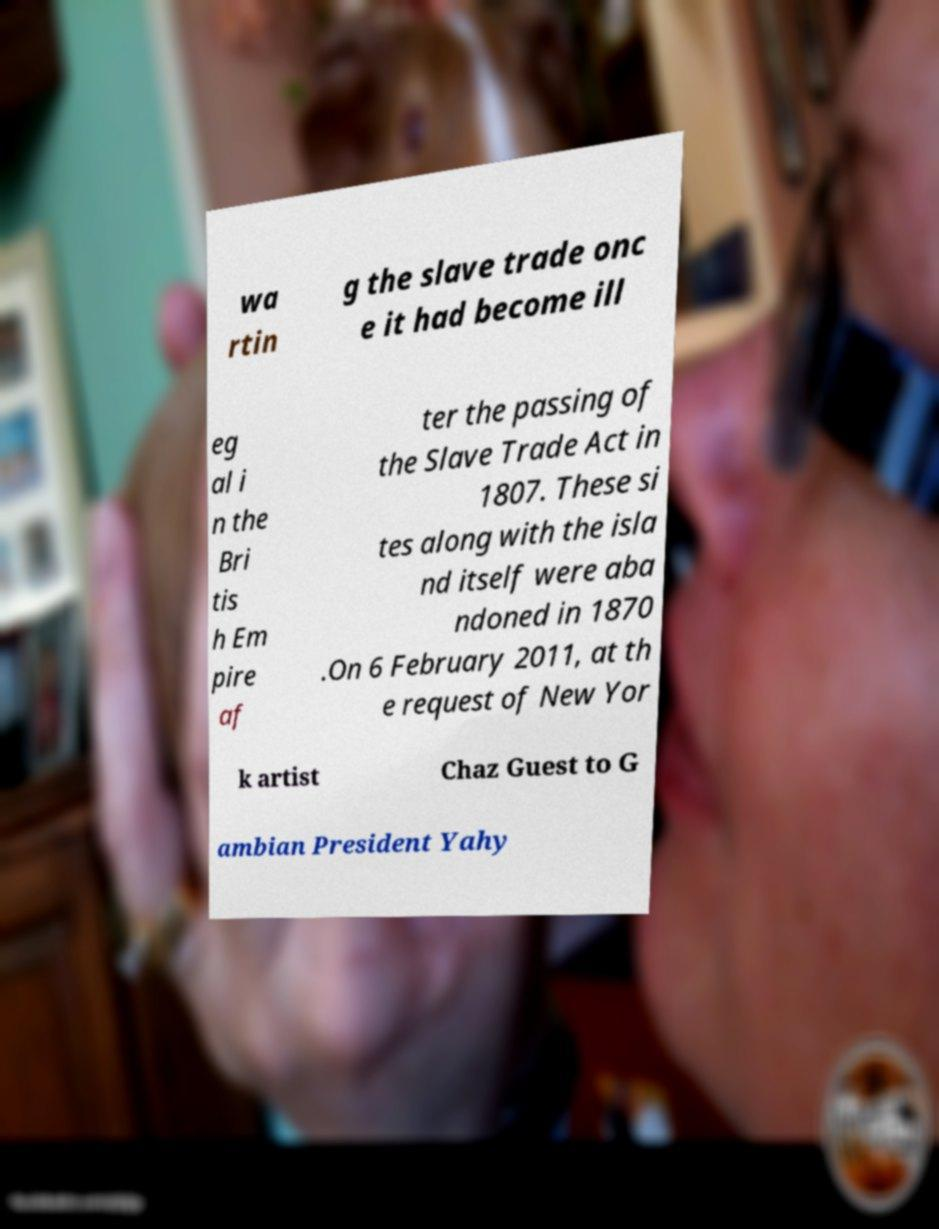Could you extract and type out the text from this image? wa rtin g the slave trade onc e it had become ill eg al i n the Bri tis h Em pire af ter the passing of the Slave Trade Act in 1807. These si tes along with the isla nd itself were aba ndoned in 1870 .On 6 February 2011, at th e request of New Yor k artist Chaz Guest to G ambian President Yahy 